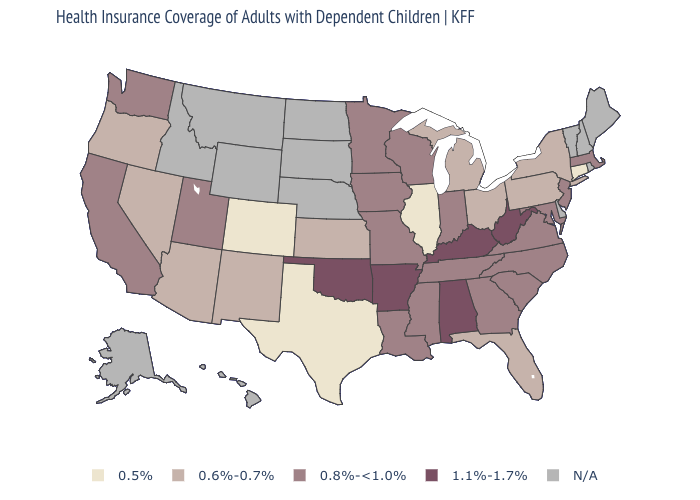Name the states that have a value in the range 0.8%-<1.0%?
Short answer required. California, Georgia, Indiana, Iowa, Louisiana, Maryland, Massachusetts, Minnesota, Mississippi, Missouri, New Jersey, North Carolina, South Carolina, Tennessee, Utah, Virginia, Washington, Wisconsin. What is the value of Oregon?
Answer briefly. 0.6%-0.7%. Among the states that border Connecticut , which have the lowest value?
Concise answer only. New York. Name the states that have a value in the range 0.5%?
Answer briefly. Colorado, Connecticut, Illinois, Texas. Which states have the highest value in the USA?
Be succinct. Alabama, Arkansas, Kentucky, Oklahoma, West Virginia. Among the states that border North Carolina , which have the lowest value?
Give a very brief answer. Georgia, South Carolina, Tennessee, Virginia. Which states have the lowest value in the South?
Concise answer only. Texas. What is the value of Massachusetts?
Quick response, please. 0.8%-<1.0%. What is the lowest value in the USA?
Be succinct. 0.5%. How many symbols are there in the legend?
Answer briefly. 5. Among the states that border Michigan , which have the highest value?
Keep it brief. Indiana, Wisconsin. Name the states that have a value in the range 0.6%-0.7%?
Give a very brief answer. Arizona, Florida, Kansas, Michigan, Nevada, New Mexico, New York, Ohio, Oregon, Pennsylvania. What is the value of New Jersey?
Quick response, please. 0.8%-<1.0%. Which states have the lowest value in the USA?
Write a very short answer. Colorado, Connecticut, Illinois, Texas. Does the first symbol in the legend represent the smallest category?
Answer briefly. Yes. 